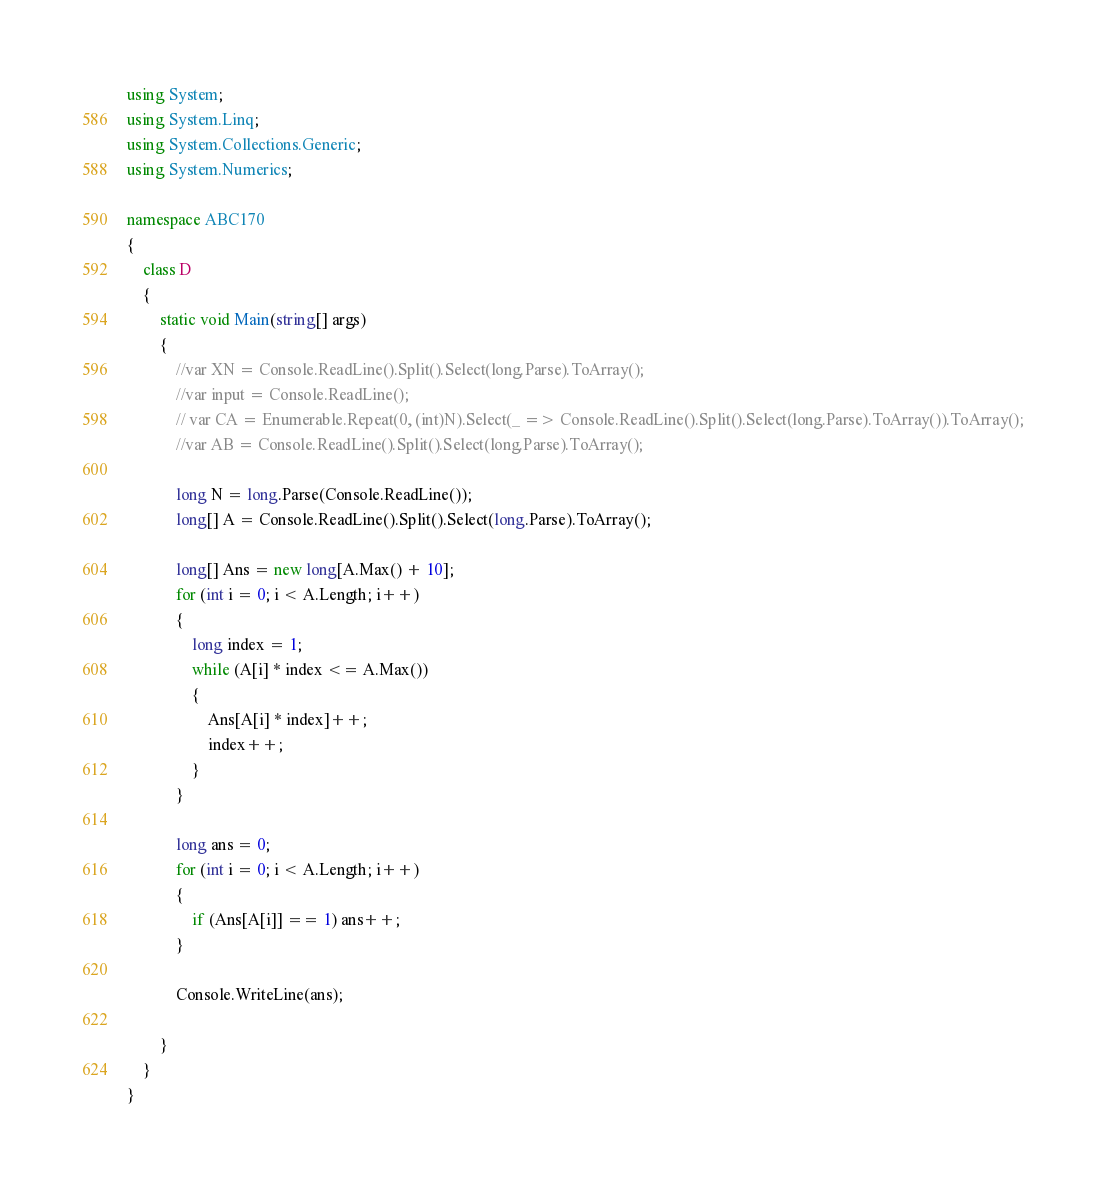<code> <loc_0><loc_0><loc_500><loc_500><_C#_>using System;
using System.Linq;
using System.Collections.Generic;
using System.Numerics;

namespace ABC170
{
    class D
    {
        static void Main(string[] args)
        {
            //var XN = Console.ReadLine().Split().Select(long.Parse).ToArray();
            //var input = Console.ReadLine();
            // var CA = Enumerable.Repeat(0, (int)N).Select(_ => Console.ReadLine().Split().Select(long.Parse).ToArray()).ToArray();
            //var AB = Console.ReadLine().Split().Select(long.Parse).ToArray();

            long N = long.Parse(Console.ReadLine());
            long[] A = Console.ReadLine().Split().Select(long.Parse).ToArray();

            long[] Ans = new long[A.Max() + 10];
            for (int i = 0; i < A.Length; i++)
            {
                long index = 1;
                while (A[i] * index <= A.Max())
                {
                    Ans[A[i] * index]++;
                    index++;
                }
            }

            long ans = 0;
            for (int i = 0; i < A.Length; i++)
            {
                if (Ans[A[i]] == 1) ans++;
            }

            Console.WriteLine(ans);

        }
    }
}
</code> 